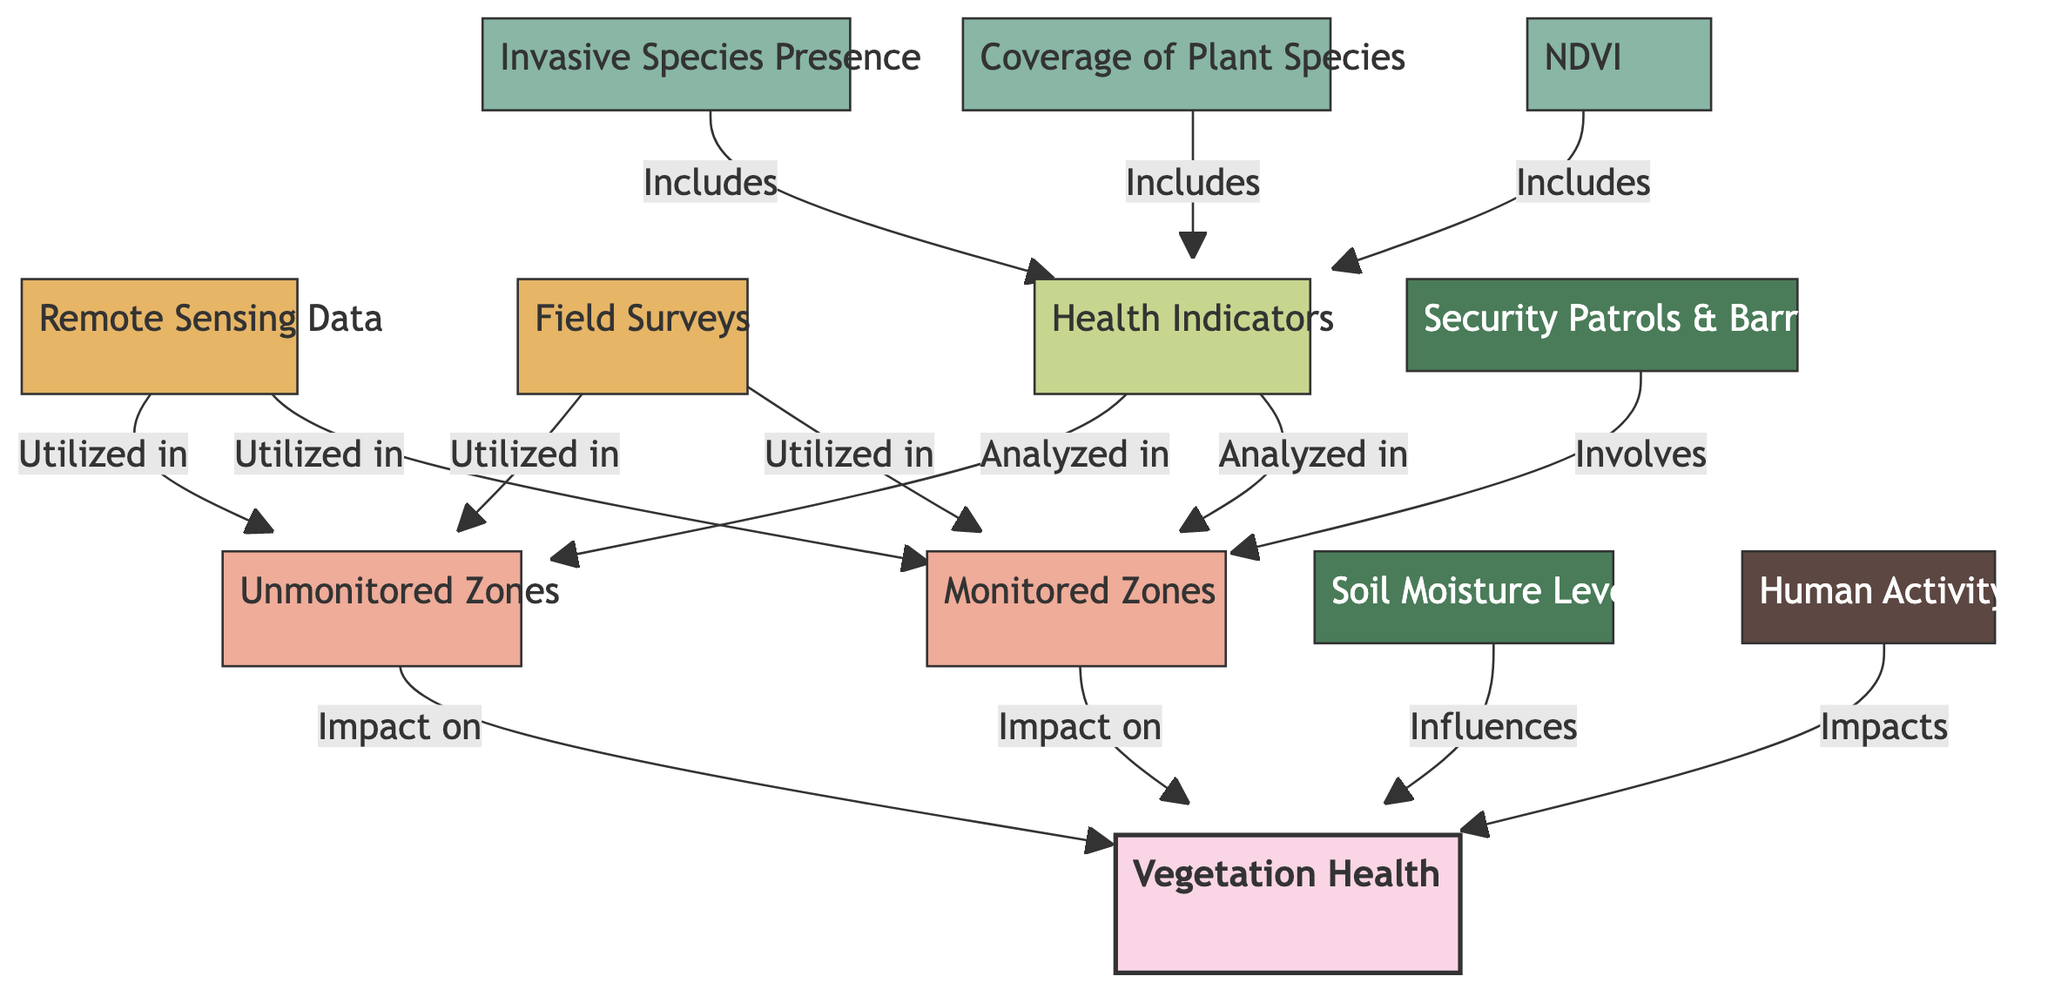What are the two main categories of zones analyzed in the diagram? The diagram identifies two primary categories: Monitored Zones and Unmonitored Zones, as represented by the corresponding nodes.
Answer: Monitored Zones, Unmonitored Zones What type of data is utilized in both Monitored and Unmonitored Zones? The diagram indicates that both Monitored Zones and Unmonitored Zones utilize Remote Sensing Data and Field Surveys, which are both data nodes linked to these categories.
Answer: Remote Sensing Data, Field Surveys How many health indicators are analyzed in the zones? The diagram shows that there are three health indicators (NDVI, Coverage of Plant Species, Invasive Species Presence) included under the Health Indicators node linked to both Monitored and Unmonitored Zones.
Answer: Three What influences Vegetation Health according to the diagram? The diagram identifies two factors that influence Vegetation Health: Soil Moisture Levels and Human Activity, connected to the Vegetation Health node.
Answer: Soil Moisture Levels, Human Activity Which measure involves the Monitored Zones? The diagram indicates that Security Patrols & Barriers is the measure that specifically involves the Monitored Zones, as it's directly connected to this category node.
Answer: Security Patrols & Barriers How are the health indicators related to NDVI? The diagram shows that NDVI is included as one of the health indicators, meaning it contributes to the analysis of health indicators in both monitored and unmonitored zones.
Answer: Included What type of information does Remote Sensing Data provide in the diagram? Remote Sensing Data is linked to both Monitored and Unmonitored Zones, indicating it provides spatial information vital for assessing vegetation health in both areas.
Answer: Spatial information What aspect does the diagram assess concerning Security Measures? The diagram assesses the impact of Security Patrols & Barriers on Vegetation Health in Monitored Zones, which shows a relationship as an influencing factor.
Answer: Impact on Vegetation Health How many primary nodes are there in the diagram? The diagram consists of a total of twelve primary nodes, including categories, data, parameters, indicators, measures, and factors, which can be counted directly in the diagram.
Answer: Twelve 